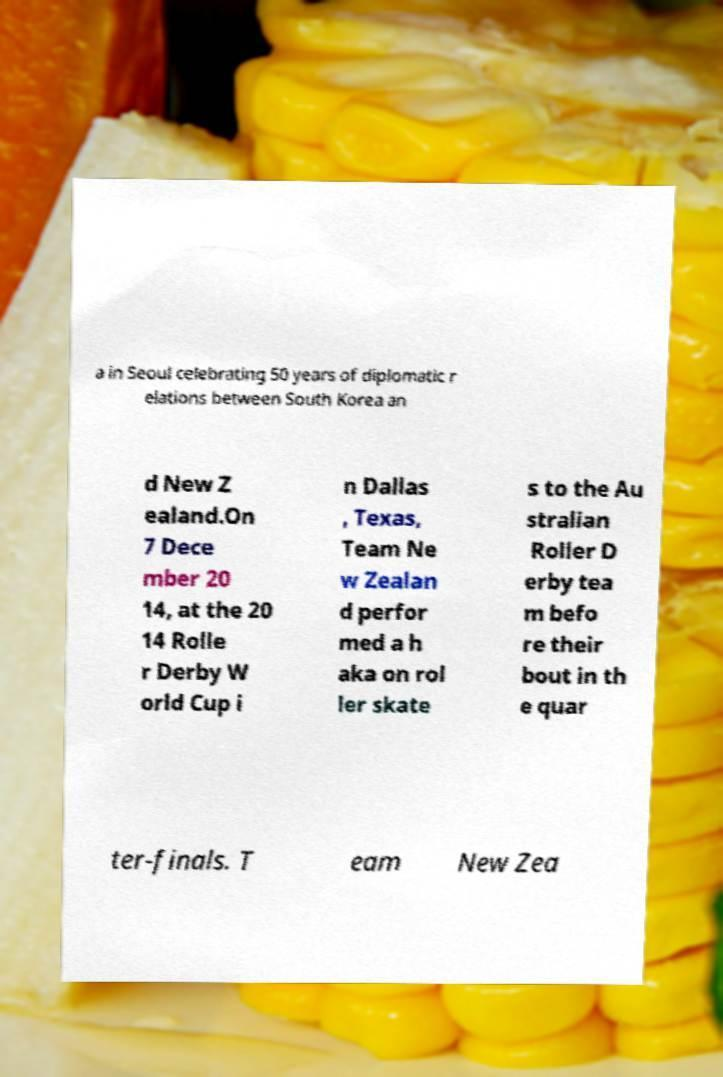What messages or text are displayed in this image? I need them in a readable, typed format. a in Seoul celebrating 50 years of diplomatic r elations between South Korea an d New Z ealand.On 7 Dece mber 20 14, at the 20 14 Rolle r Derby W orld Cup i n Dallas , Texas, Team Ne w Zealan d perfor med a h aka on rol ler skate s to the Au stralian Roller D erby tea m befo re their bout in th e quar ter-finals. T eam New Zea 